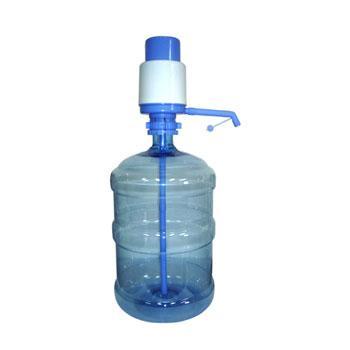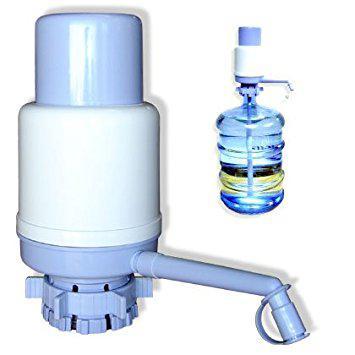The first image is the image on the left, the second image is the image on the right. Examine the images to the left and right. Is the description "Every image has a fully stocked tower of blue water jugs with at least three levels." accurate? Answer yes or no. No. The first image is the image on the left, the second image is the image on the right. For the images shown, is this caption "An image contains a rack holding large water bottles." true? Answer yes or no. No. 